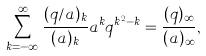Convert formula to latex. <formula><loc_0><loc_0><loc_500><loc_500>\sum _ { k = - \infty } ^ { \infty } \frac { ( q / a ) _ { k } } { ( a ) _ { k } } a ^ { k } q ^ { k ^ { 2 } - k } = \frac { ( q ) _ { \infty } } { ( a ) _ { \infty } } ,</formula> 